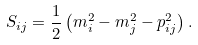<formula> <loc_0><loc_0><loc_500><loc_500>S _ { i j } = \frac { 1 } { 2 } \left ( m _ { i } ^ { 2 } - m _ { j } ^ { 2 } - p _ { i j } ^ { 2 } \right ) .</formula> 